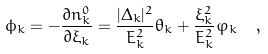<formula> <loc_0><loc_0><loc_500><loc_500>\phi _ { k } = - \frac { \partial n _ { k } ^ { 0 } } { \partial \xi _ { k } } = \frac { | \Delta _ { k } | ^ { 2 } } { E _ { k } ^ { 2 } } \theta _ { k } + \frac { \xi _ { k } ^ { 2 } } { E _ { k } ^ { 2 } } \varphi _ { k } \ \ ,</formula> 